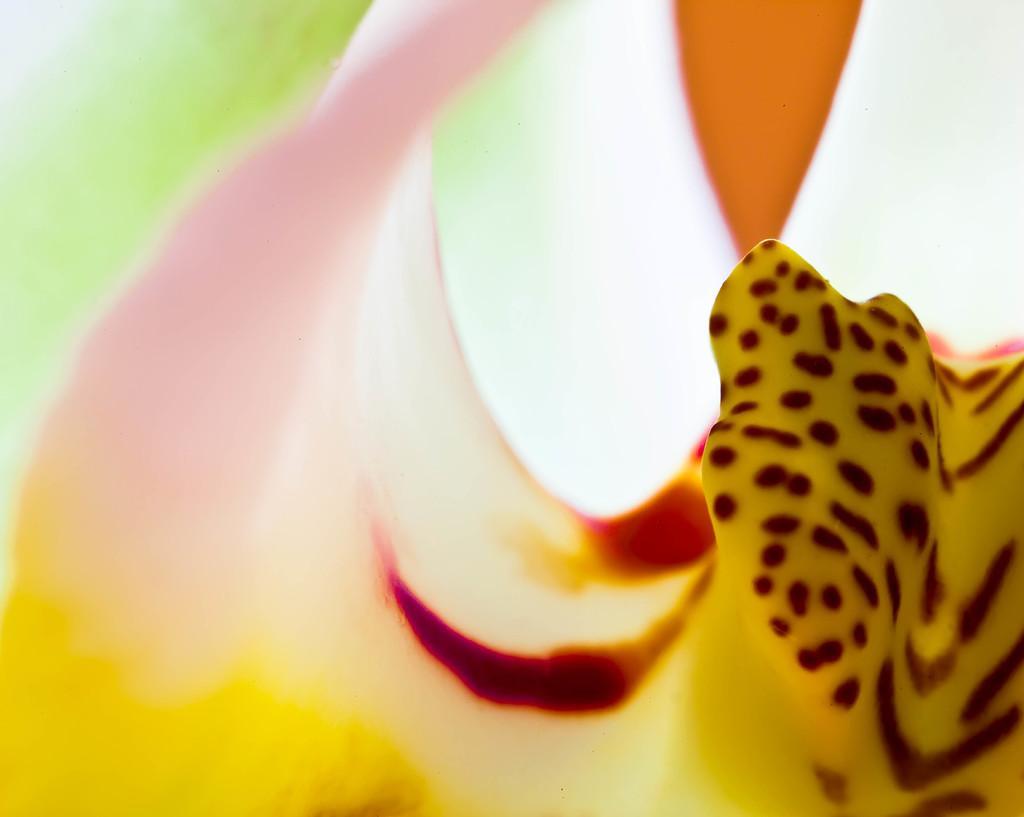In one or two sentences, can you explain what this image depicts? Here we can see a close up view of an object and we can also see the painting present on it over there. 